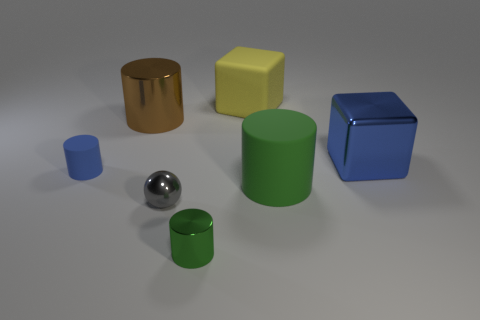There is a large block that is behind the large blue cube; how many big blue things are right of it?
Your response must be concise. 1. There is a metal cylinder in front of the big rubber cylinder; does it have the same size as the metallic cylinder behind the big green rubber cylinder?
Offer a terse response. No. What number of big gray matte balls are there?
Your answer should be compact. 0. How many big blue cubes have the same material as the tiny green object?
Provide a succinct answer. 1. Is the number of gray objects behind the small gray metal ball the same as the number of large yellow things?
Your answer should be compact. No. There is another object that is the same color as the tiny matte object; what is it made of?
Your response must be concise. Metal. Do the blue cylinder and the green cylinder right of the yellow block have the same size?
Make the answer very short. No. How many other things are there of the same size as the gray ball?
Keep it short and to the point. 2. What number of other things are there of the same color as the matte block?
Your response must be concise. 0. Is there anything else that has the same size as the green shiny cylinder?
Your response must be concise. Yes. 